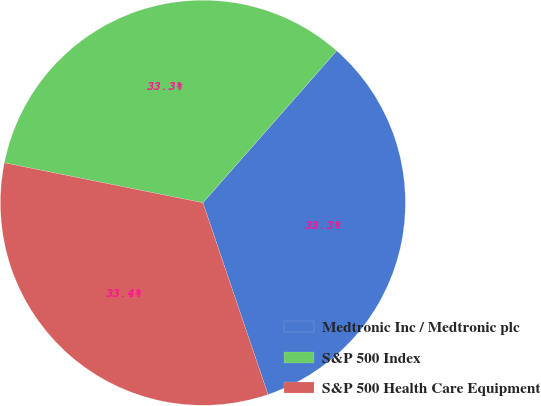Convert chart. <chart><loc_0><loc_0><loc_500><loc_500><pie_chart><fcel>Medtronic Inc / Medtronic plc<fcel>S&P 500 Index<fcel>S&P 500 Health Care Equipment<nl><fcel>33.3%<fcel>33.33%<fcel>33.37%<nl></chart> 